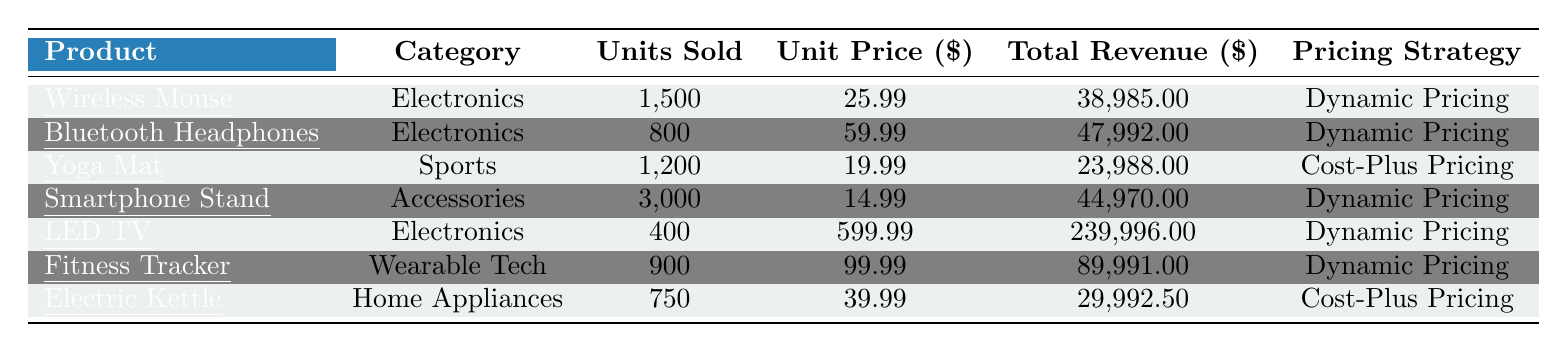What is the total revenue generated by the Wireless Mouse? The table indicates that the total revenue for the Wireless Mouse is listed in the "Total Revenue" column as 38,985.00.
Answer: 38,985.00 How many units of Bluetooth Headphones were sold? The "Units Sold" column shows that the number of Bluetooth Headphones sold is 800.
Answer: 800 Which product had the highest unit price? By comparing the "Unit Price" values, the LED TV has the highest unit price at 599.99.
Answer: LED TV What is the average discount for products sold using Dynamic Pricing? The discounts for Dynamic Pricing products are 5.00, 10.00, 3.00, 50.00, and 15.00. Summing these gives 5 + 10 + 3 + 50 + 15 = 83. Dividing by the number of products (5) results in an average discount of 83/5 = 16.6.
Answer: 16.6 Which category has the most units sold? The units sold for each category are as follows: Electronics (2,700), Sports (1,200), Accessories (3,000), and Wearable Tech (900). Accessories has the highest total at 3,000 units.
Answer: Accessories What is the total revenue generated by products in the Electronics category? The total revenue for Electronics is the sum of that category's revenues: 38,985.00 (Wireless Mouse) + 47,992.00 (Bluetooth Headphones) + 239,996.00 (LED TV) = 326,973.00.
Answer: 326,973.00 Did the Electric Kettle have a higher average discount compared to the Wireless Mouse? The average discount for the Electric Kettle is 8.00, while for the Wireless Mouse, it's 5.00. Since 8.00 is greater than 5.00, it's true.
Answer: Yes What is the total number of units sold across all products? To find the total units sold, sum up all 'Units Sold': (1500 + 800 + 1200 + 3000 + 400 + 900 + 750 = 7550).
Answer: 7550 Which product recorded the highest total revenue? Looking at the "Total Revenue" values, the LED TV generated the most revenue at 239,996.00.
Answer: LED TV How much more total revenue did the Smart Phone Stand generate compared to the Yoga Mat? The total revenue for the Smartphone Stand is 44,970.00 and for the Yoga Mat it is 23,988.00. The difference is 44,970.00 - 23,988.00 = 20,982.00.
Answer: 20,982.00 